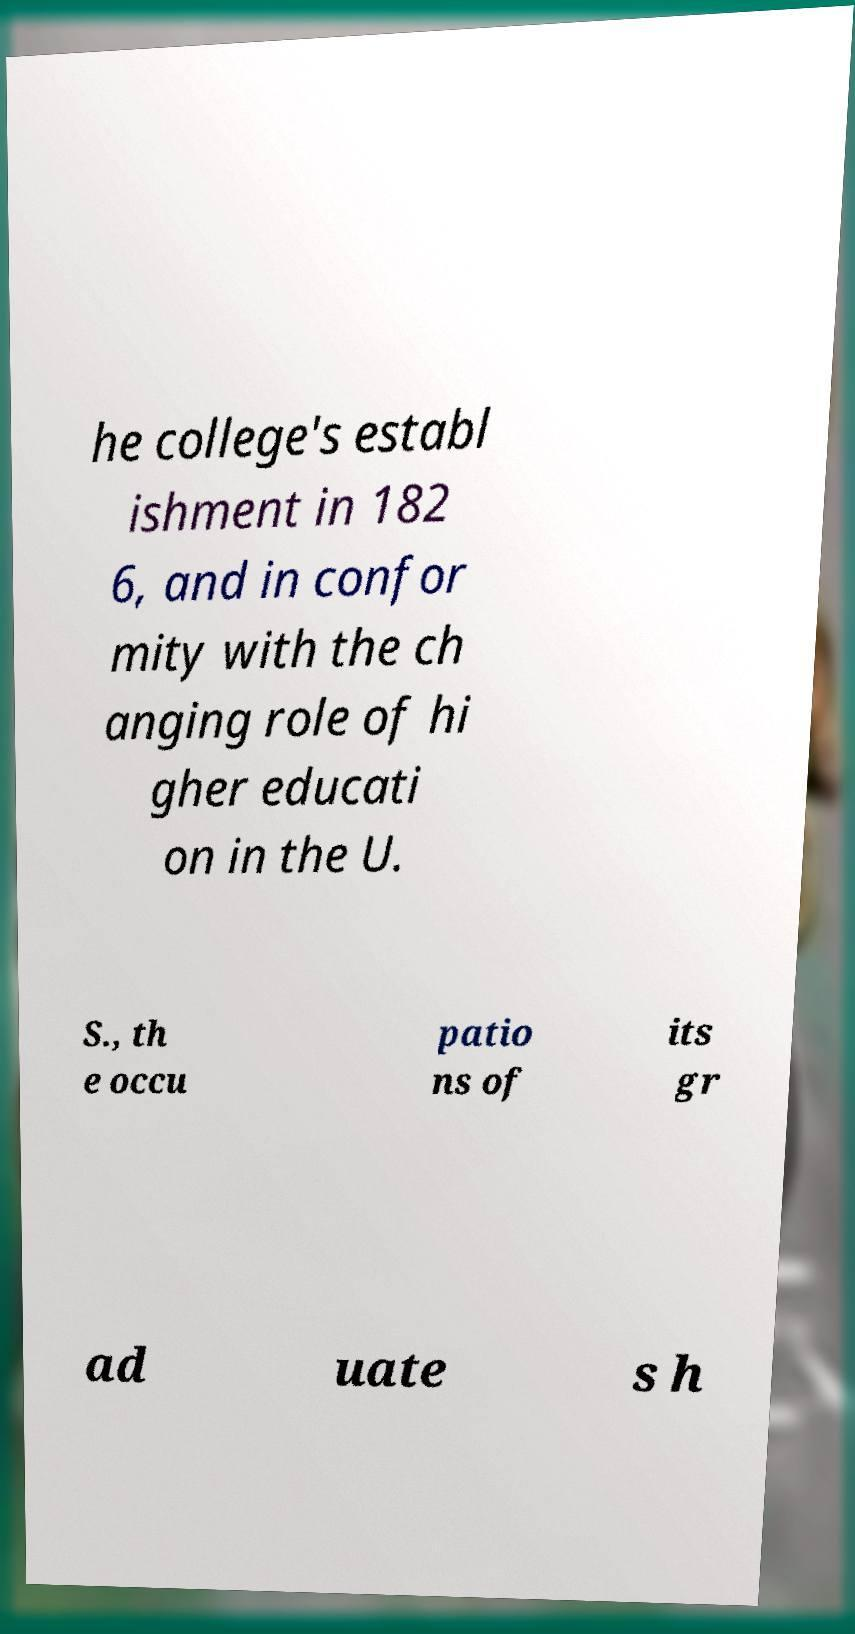For documentation purposes, I need the text within this image transcribed. Could you provide that? he college's establ ishment in 182 6, and in confor mity with the ch anging role of hi gher educati on in the U. S., th e occu patio ns of its gr ad uate s h 